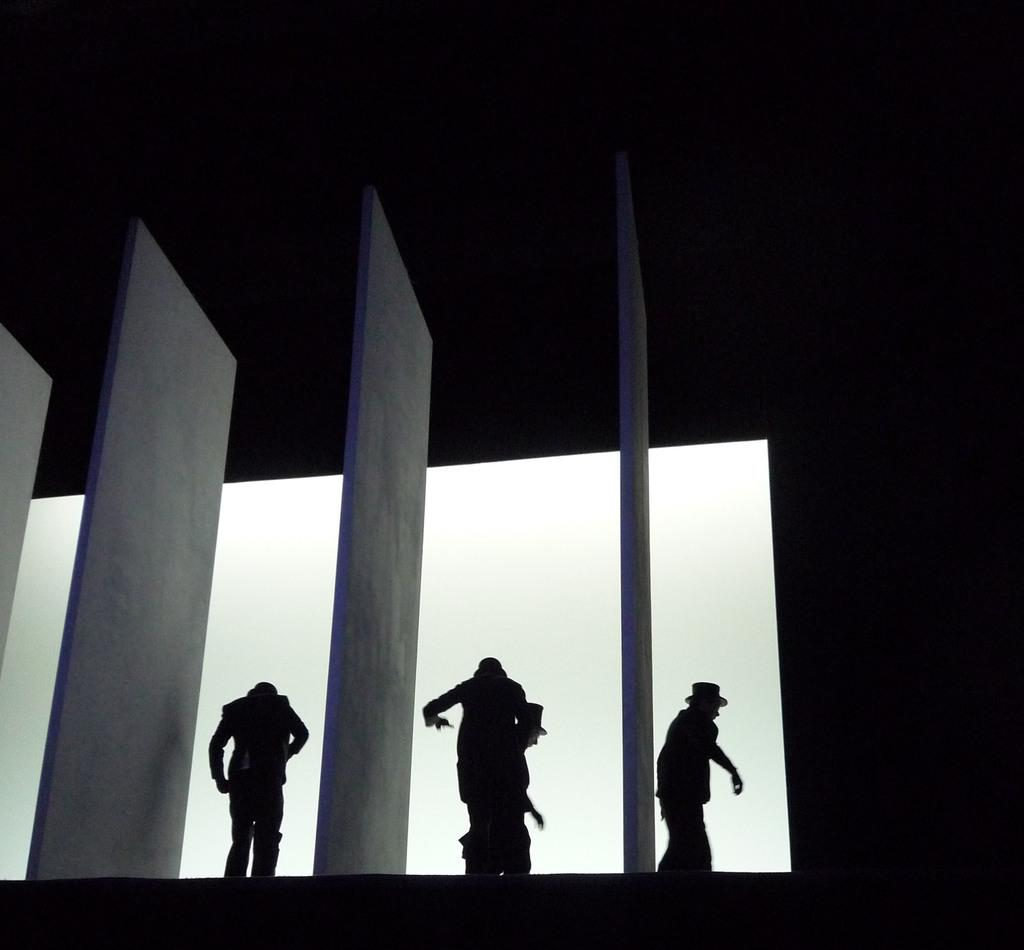How many people are in the image? There are four people in the center of the image. Can you describe the location of the people in the image? The four people are in the center of the image. What is visible at the right side of the image? There is a wall at the right side of the image. What type of event is taking place in space in the image? There is no event taking place in space in the image; it features four people and a wall. Can you describe the type of sofa present in the image? There is no sofa present in the image. 